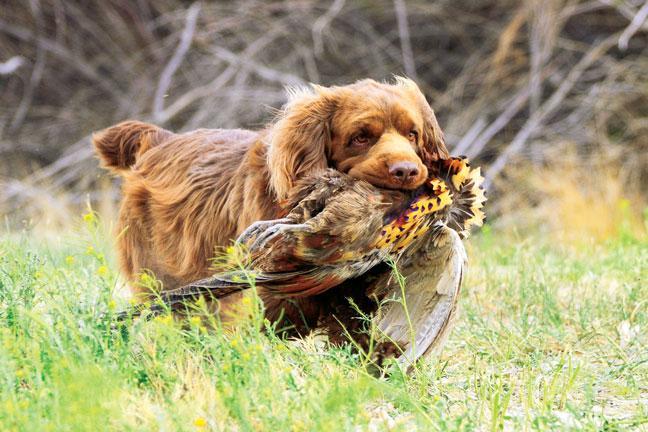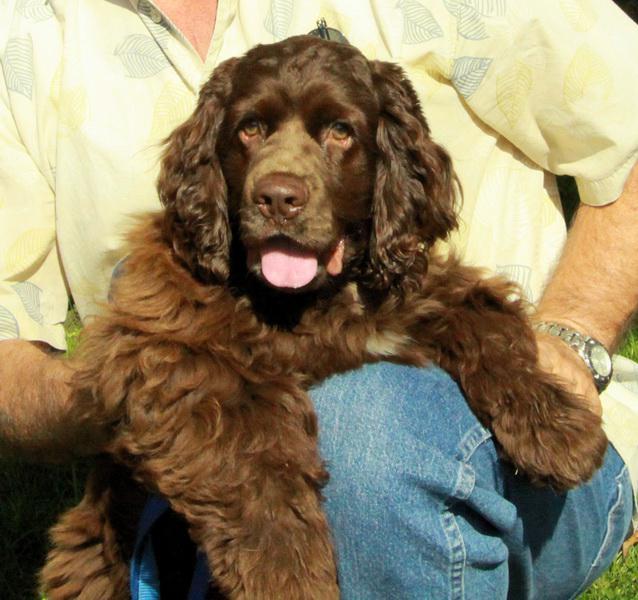The first image is the image on the left, the second image is the image on the right. Analyze the images presented: Is the assertion "In the left image, there's a dog running through the grass while carrying something in its mouth." valid? Answer yes or no. Yes. The first image is the image on the left, the second image is the image on the right. For the images displayed, is the sentence "The dog in the right image is lying down on the ground." factually correct? Answer yes or no. No. 